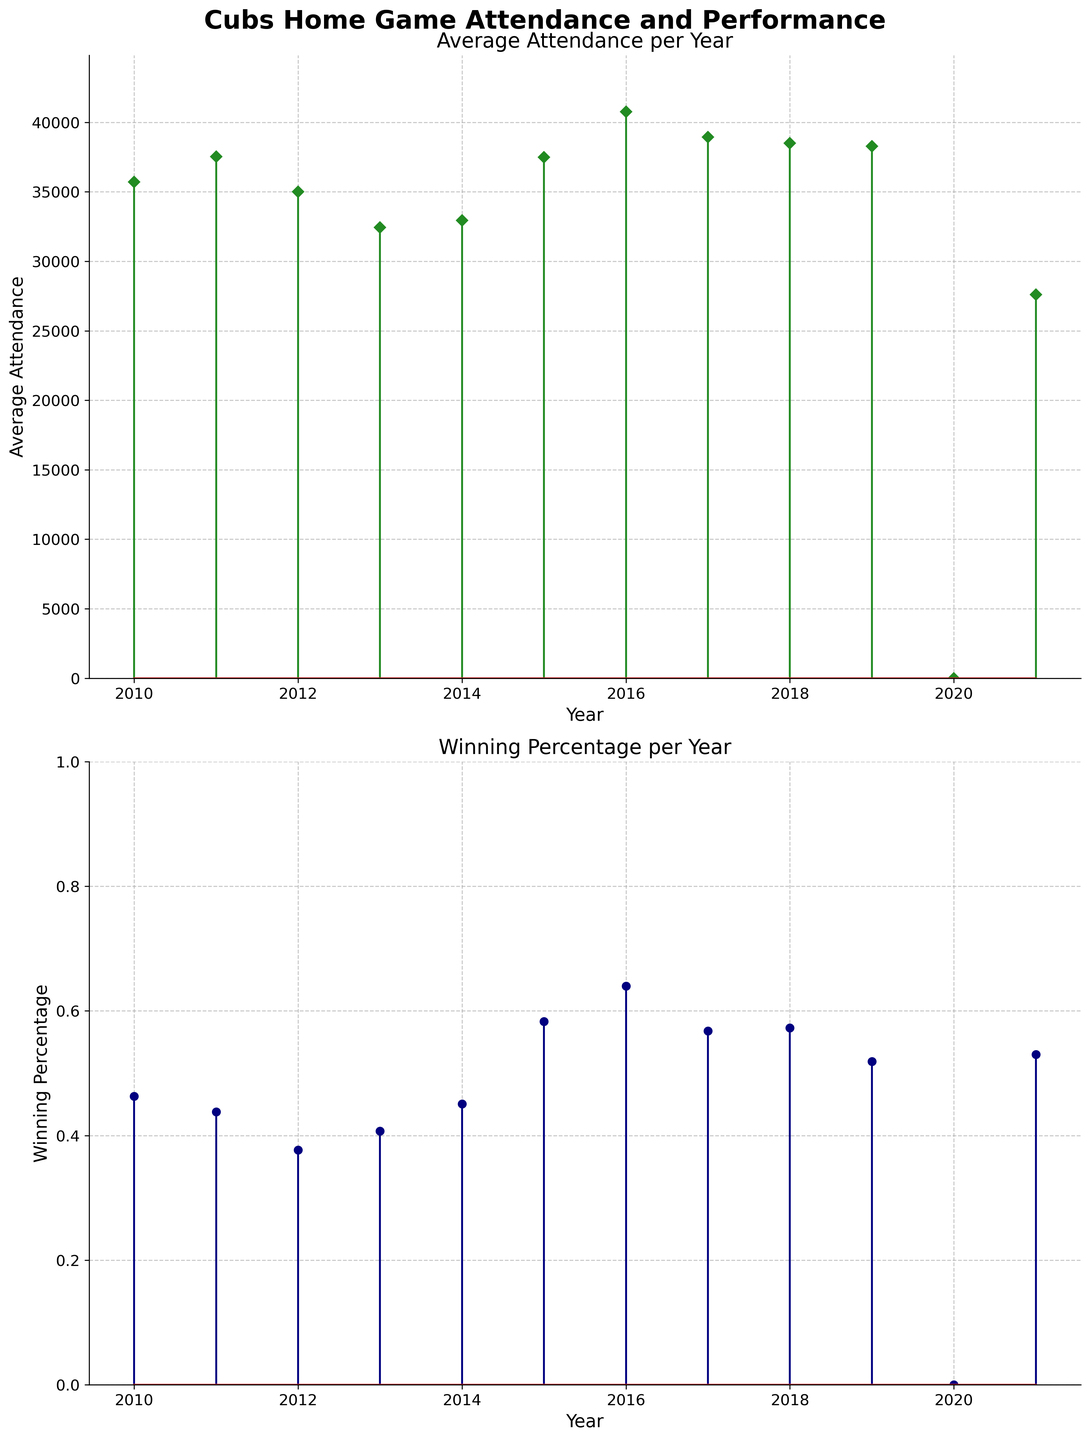What is the title of the figure? The title of the figure is located at the top center of the chart, and it is written in bold, large font. Reading the title helps in understanding the overall topic of the figure.
Answer: Cubs Home Game Attendance and Performance What is the average attendance value for the year 2017? To find the average attendance for a specific year, locate the year on the x-axis of the first plot, then identify the corresponding stem's height. For 2017, the average attendance is represented by an orange diamond.
Answer: 38934 Which year has the highest winning percentage? To determine the year with the highest winning percentage, observe the second sub-plot and identify the stem with the maximum height among all years. Track the corresponding year along the x-axis.
Answer: 2016 How does the winning percentage for 2013 compare to that of 2014? Locate the stems for 2013 and 2014 in the second sub-plot. Compare their heights to determine which is taller, indicating a higher winning percentage. In 2013, it is lower compared to 2014.
Answer: 2013 has a lower winning percentage than 2014 What is the total average attendance over the years 2018 and 2019? Summing the average attendances for 2018 and 2019 requires looking at both corresponding stems on the first plot. Determine their values and add them together.
Answer: 38502 + 38278 = 76780 What year marks the drop to zero attendance? Scan the first plot to find the year with a stem dropping to the baseline (0 attendance). This is straightforward as there is only one year with zero attendance.
Answer: 2020 By how much did average attendance drop from 2019 to 2021? To find the drop, locate the average attendances for 2019 and 2021 on the first plot. Subtract the 2021 value from the 2019 value to calculate the decrease.
Answer: 38278 - 27601 = 10677 Between which two consecutive years is the largest increase in winning percentage observed? Examine the second sub-plot for consecutive years and identify the largest increase in stem height, comparing each year’s winning percentage to the next.
Answer: 2014 and 2015 What is the trend of average attendance from 2015 to 2017? Look at the first sub-plot, observe the heights of the stems for 2015, 2016, and 2017, and describe whether the stems increase or decrease. From 2015 to 2016, there is an increase, followed by a slight decrease in 2017.
Answer: Increase from 2015 to 2016, then a slight decrease to 2017 What is the combined winning percentage for 2014, 2015, and 2016? Sum up the winning percentages for these three years by locating their respective stems on the second plot, then add them together.
Answer: 0.451 + 0.583 + 0.640 = 1.674 